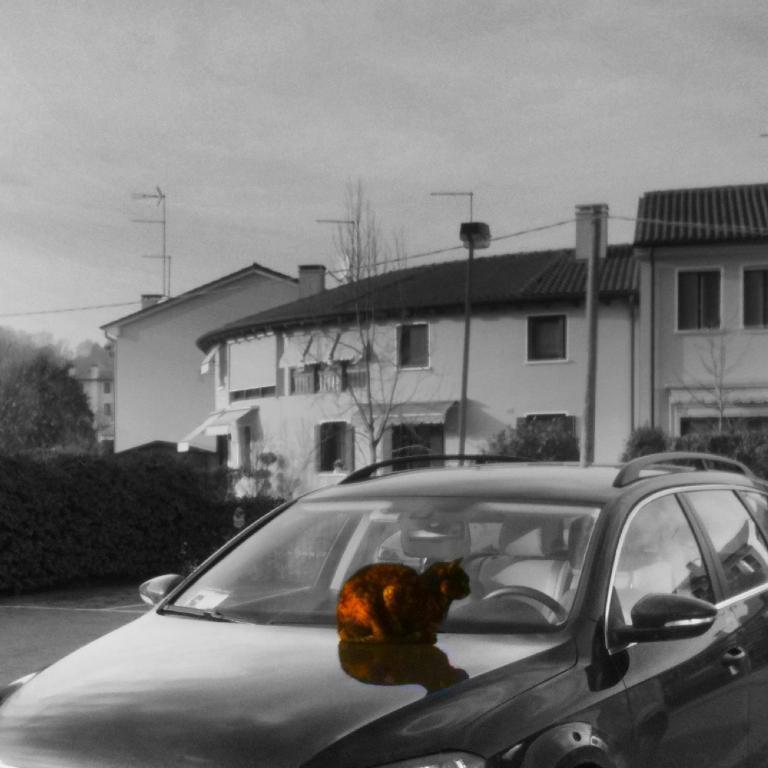How would you summarize this image in a sentence or two? It is a black and white image, there is a car and behind the car there are few buildings, in front of the buildings there are trees and poles. There is a cat sitting on the car, only the cat image is highlighted in the whole picture. 